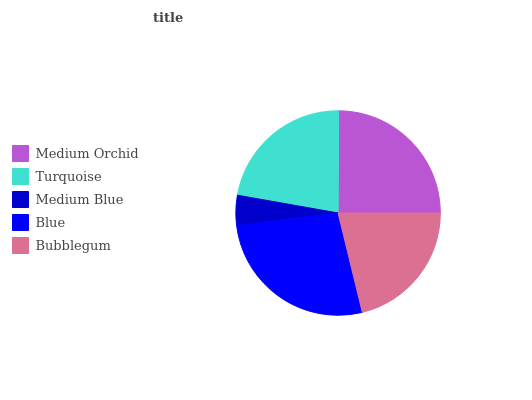Is Medium Blue the minimum?
Answer yes or no. Yes. Is Blue the maximum?
Answer yes or no. Yes. Is Turquoise the minimum?
Answer yes or no. No. Is Turquoise the maximum?
Answer yes or no. No. Is Medium Orchid greater than Turquoise?
Answer yes or no. Yes. Is Turquoise less than Medium Orchid?
Answer yes or no. Yes. Is Turquoise greater than Medium Orchid?
Answer yes or no. No. Is Medium Orchid less than Turquoise?
Answer yes or no. No. Is Turquoise the high median?
Answer yes or no. Yes. Is Turquoise the low median?
Answer yes or no. Yes. Is Medium Blue the high median?
Answer yes or no. No. Is Bubblegum the low median?
Answer yes or no. No. 